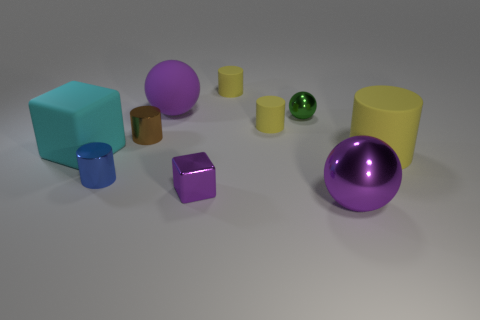The big sphere that is made of the same material as the cyan thing is what color?
Your answer should be compact. Purple. Is the number of shiny cubes less than the number of spheres?
Keep it short and to the point. Yes. What material is the purple thing that is behind the small metal cylinder in front of the yellow cylinder in front of the brown object?
Make the answer very short. Rubber. What is the material of the green object?
Give a very brief answer. Metal. There is a large sphere that is behind the purple metallic sphere; does it have the same color as the tiny cylinder behind the green sphere?
Make the answer very short. No. Are there more big blocks than brown metallic blocks?
Your response must be concise. Yes. What number of rubber cubes have the same color as the large rubber cylinder?
Your response must be concise. 0. What color is the other metal object that is the same shape as the blue thing?
Make the answer very short. Brown. There is a yellow cylinder that is both behind the big cyan block and in front of the tiny sphere; what is it made of?
Offer a terse response. Rubber. Does the big purple sphere that is behind the purple metallic ball have the same material as the cube that is in front of the tiny blue metallic cylinder?
Your answer should be compact. No. 